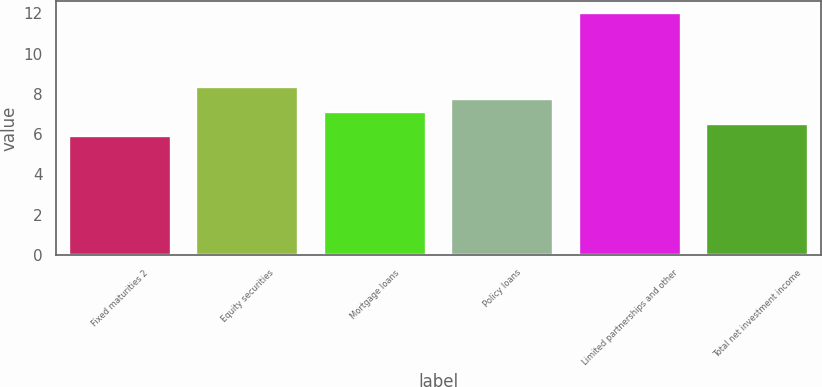Convert chart to OTSL. <chart><loc_0><loc_0><loc_500><loc_500><bar_chart><fcel>Fixed maturities 2<fcel>Equity securities<fcel>Mortgage loans<fcel>Policy loans<fcel>Limited partnerships and other<fcel>Total net investment income<nl><fcel>5.9<fcel>8.34<fcel>7.12<fcel>7.73<fcel>12<fcel>6.51<nl></chart> 